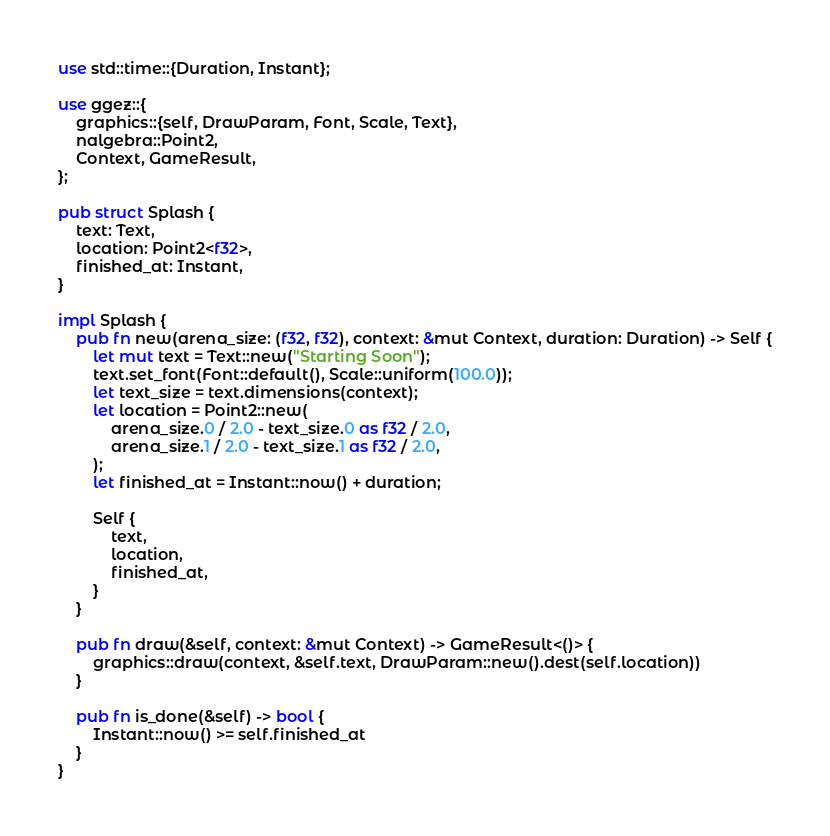<code> <loc_0><loc_0><loc_500><loc_500><_Rust_>use std::time::{Duration, Instant};

use ggez::{
    graphics::{self, DrawParam, Font, Scale, Text},
    nalgebra::Point2,
    Context, GameResult,
};

pub struct Splash {
    text: Text,
    location: Point2<f32>,
    finished_at: Instant,
}

impl Splash {
    pub fn new(arena_size: (f32, f32), context: &mut Context, duration: Duration) -> Self {
        let mut text = Text::new("Starting Soon");
        text.set_font(Font::default(), Scale::uniform(100.0));
        let text_size = text.dimensions(context);
        let location = Point2::new(
            arena_size.0 / 2.0 - text_size.0 as f32 / 2.0,
            arena_size.1 / 2.0 - text_size.1 as f32 / 2.0,
        );
        let finished_at = Instant::now() + duration;

        Self {
            text,
            location,
            finished_at,
        }
    }

    pub fn draw(&self, context: &mut Context) -> GameResult<()> {
        graphics::draw(context, &self.text, DrawParam::new().dest(self.location))
    }

    pub fn is_done(&self) -> bool {
        Instant::now() >= self.finished_at
    }
}
</code> 